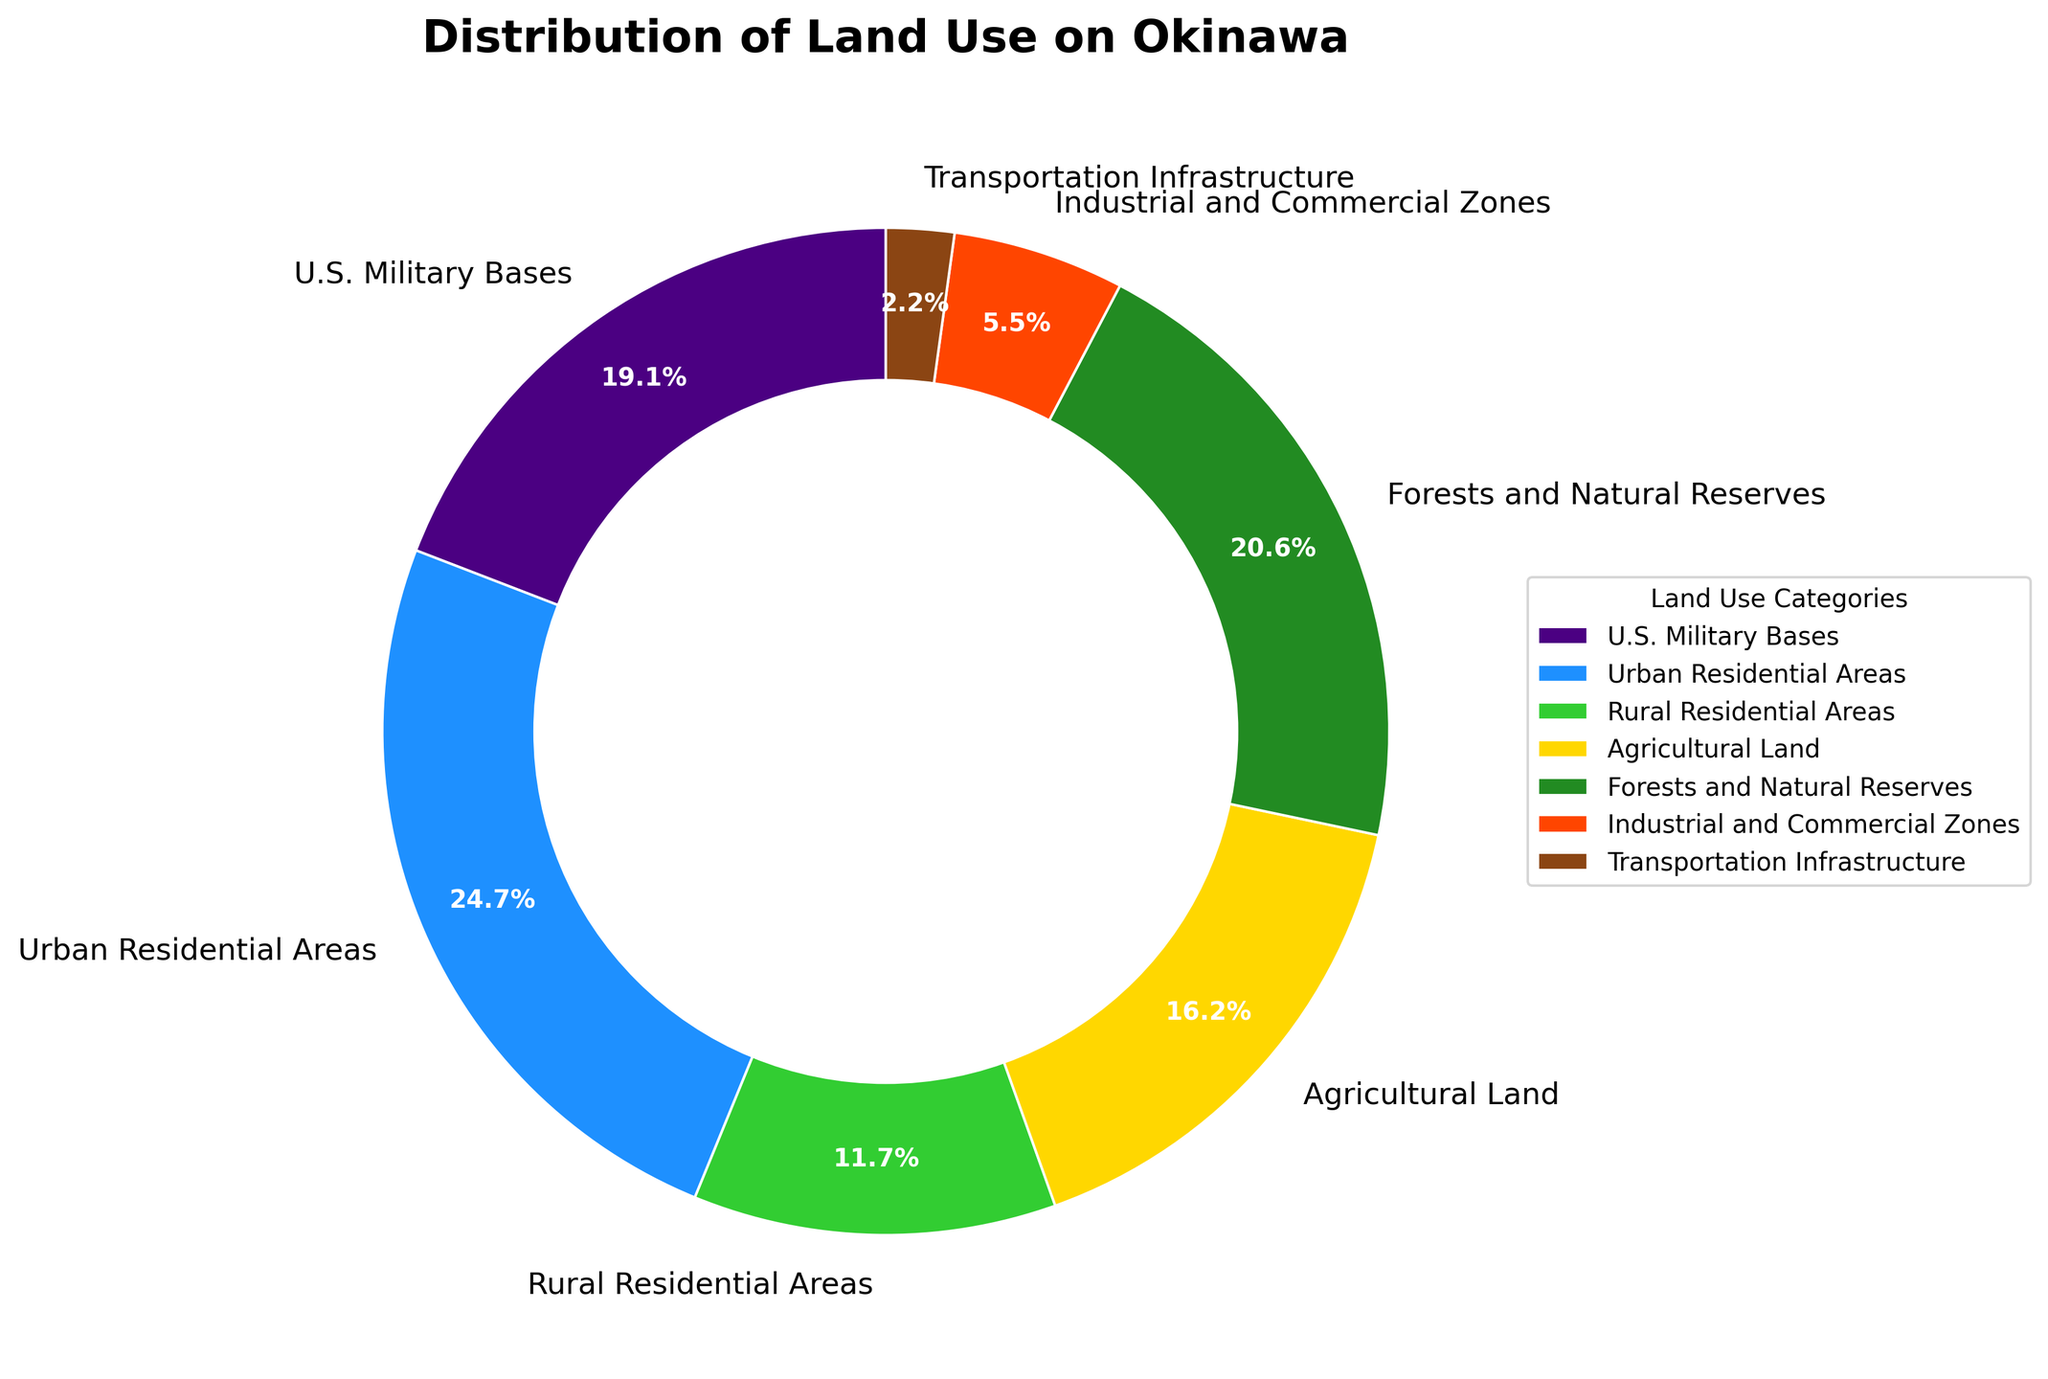Which land use category takes up the most space? Look at the wedge with the largest percentage. The Urban Residential Areas have the largest percentage at 23.7%.
Answer: Urban Residential Areas What is the percentage difference between U.S. Military Bases and Forests and Natural Reserves? Subtract the percentage of U.S. Military Bases (18.4%) from the percentage of Forests and Natural Reserves (19.8%). Thus, 19.8% - 18.4% = 1.4%.
Answer: 1.4% What are the total percentages of all residential areas combined? Add the percentages of Urban Residential Areas (23.7%) and Rural Residential Areas (11.2%). So, 23.7% + 11.2% = 34.9%.
Answer: 34.9% Which category occupies a smaller percentage: Industrial and Commercial Zones or Transportation Infrastructure? Compare the percentages of Industrial and Commercial Zones (5.3%) and Transportation Infrastructure (2.1%). 2.1% is smaller than 5.3%.
Answer: Transportation Infrastructure How much larger is the area of Agricultural Land compared to Industrial and Commercial Zones? Subtract the percentage of Industrial and Commercial Zones (5.3%) from the percentage of Agricultural Land (15.6%). Thus, 15.6% - 5.3% = 10.3%.
Answer: 10.3% Which two land use categories are almost equal in size? Look for categories with similar percentages. U.S. Military Bases (18.4%) and Forests and Natural Reserves (19.8%) are close in percentage.
Answer: U.S. Military Bases and Forests and Natural Reserves If you were to combine Agricultural Land and Rural Residential Areas, what would be the total percentage? Add the percentages of Agricultural Land (15.6%) and Rural Residential Areas (11.2%). So, 15.6% + 11.2% = 26.8%.
Answer: 26.8% Which color wedge represents the Forests and Natural Reserves? The wedge with 19.8% represents Forests and Natural Reserves, which is colored green.
Answer: Green 